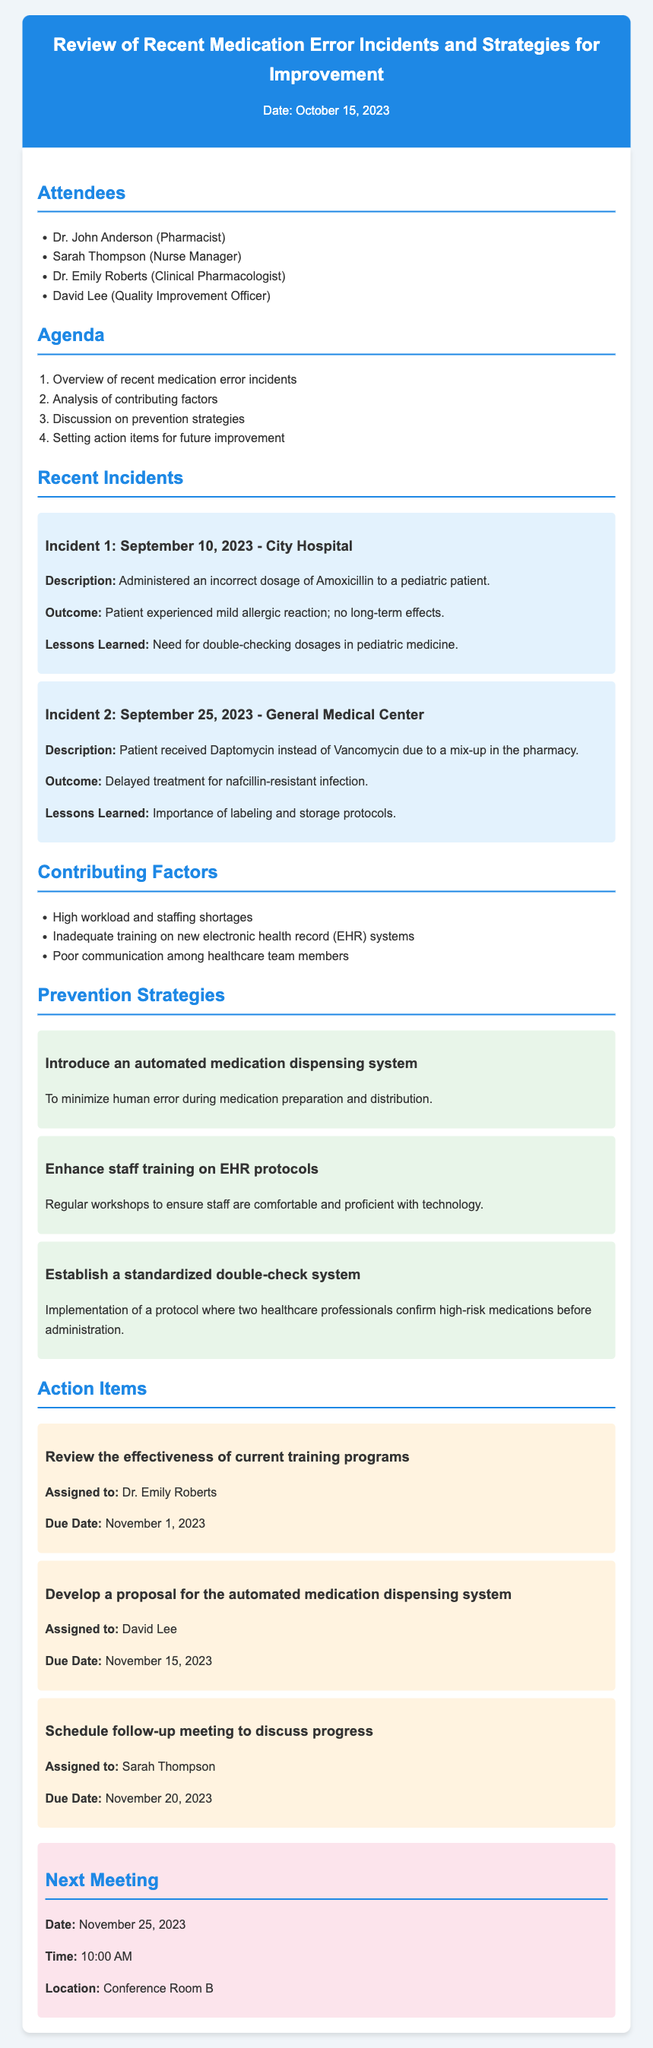What is the date of the meeting? The date of the meeting is mentioned at the top of the document as October 15, 2023.
Answer: October 15, 2023 Who is the Quality Improvement Officer? The document lists David Lee as the Quality Improvement Officer among the attendees.
Answer: David Lee What was the description of Incident 1? Incident 1's description includes administering an incorrect dosage of Amoxicillin to a pediatric patient.
Answer: Administered an incorrect dosage of Amoxicillin to a pediatric patient What is one of the contributing factors to medication errors? The document lists several contributing factors, one being high workload and staffing shortages.
Answer: High workload and staffing shortages What is the due date for reviewing current training programs? The due date for this action item is November 1, 2023, as stated in the document.
Answer: November 1, 2023 What is one proposed prevention strategy? The document outlines several strategies, one being to introduce an automated medication dispensing system.
Answer: Introduce an automated medication dispensing system How many attendees are listed in the document? The number of attendees is provided in the list within the document, which shows four names.
Answer: Four When is the next meeting scheduled? The next meeting date is stated at the end of the document, indicating it will be on November 25, 2023.
Answer: November 25, 2023 